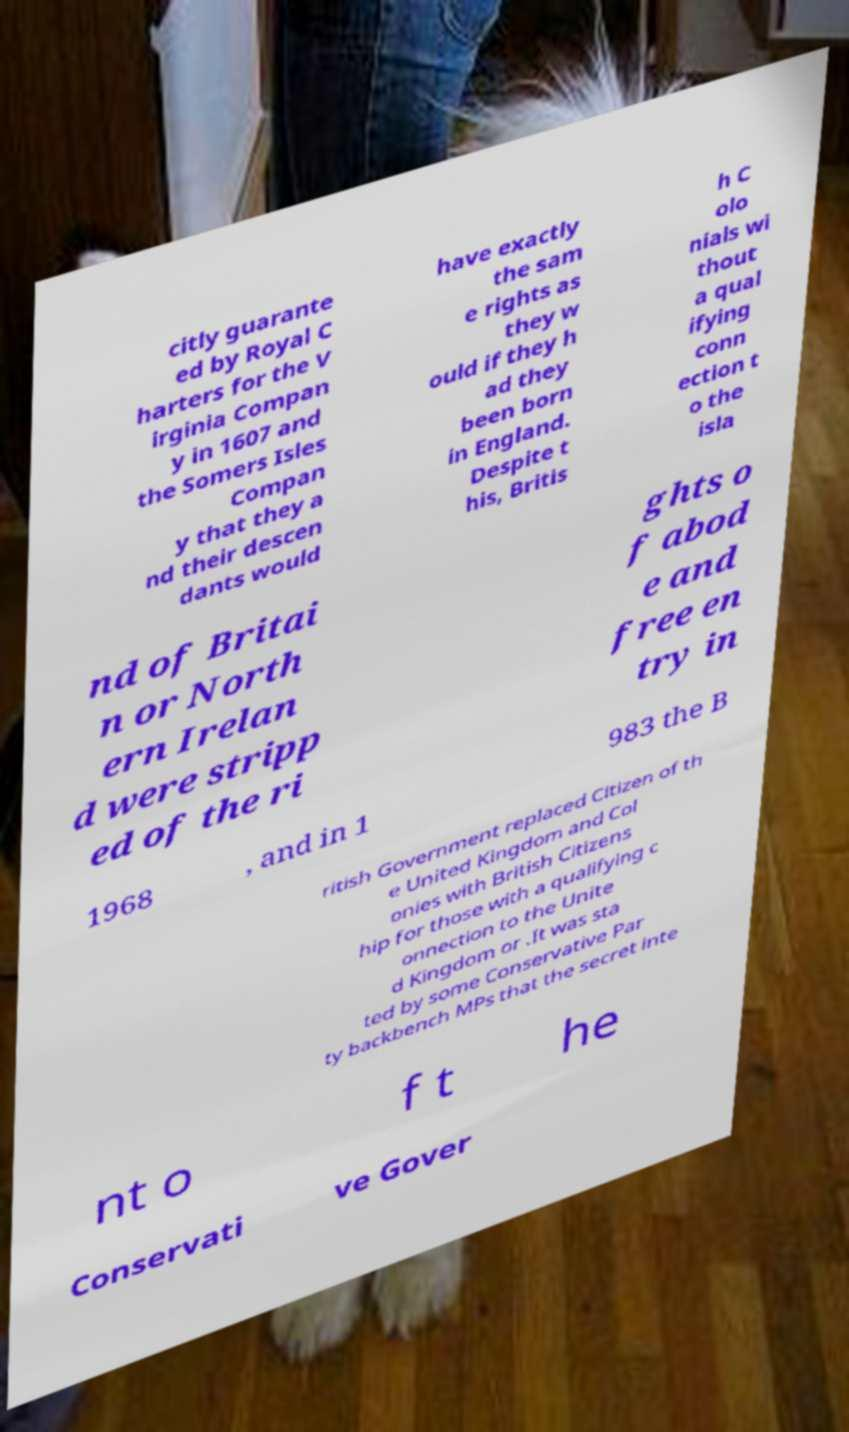Please read and relay the text visible in this image. What does it say? citly guarante ed by Royal C harters for the V irginia Compan y in 1607 and the Somers Isles Compan y that they a nd their descen dants would have exactly the sam e rights as they w ould if they h ad they been born in England. Despite t his, Britis h C olo nials wi thout a qual ifying conn ection t o the isla nd of Britai n or North ern Irelan d were stripp ed of the ri ghts o f abod e and free en try in 1968 , and in 1 983 the B ritish Government replaced Citizen of th e United Kingdom and Col onies with British Citizens hip for those with a qualifying c onnection to the Unite d Kingdom or .It was sta ted by some Conservative Par ty backbench MPs that the secret inte nt o f t he Conservati ve Gover 